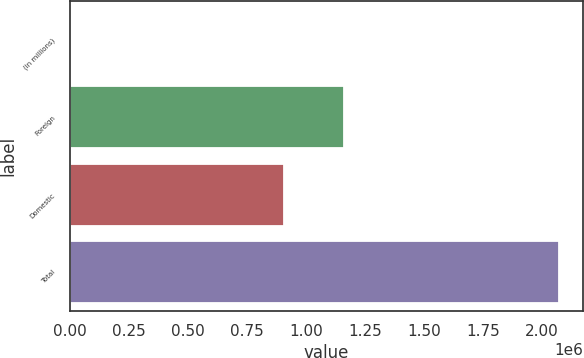<chart> <loc_0><loc_0><loc_500><loc_500><bar_chart><fcel>(in millions)<fcel>Foreign<fcel>Domestic<fcel>Total<nl><fcel>2006<fcel>1.1627e+06<fcel>907901<fcel>2.0706e+06<nl></chart> 